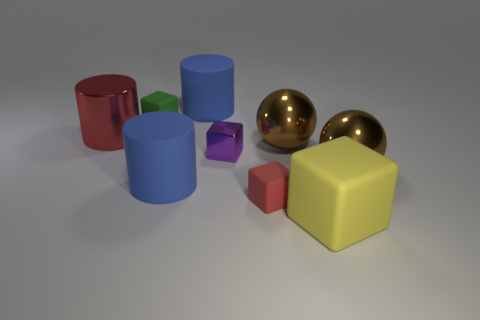Subtract all tiny green matte blocks. How many blocks are left? 3 Subtract all purple blocks. How many blocks are left? 3 Subtract all gray cubes. Subtract all red cylinders. How many cubes are left? 4 Add 1 small purple cubes. How many objects exist? 10 Subtract all cylinders. How many objects are left? 6 Add 2 red metal cylinders. How many red metal cylinders exist? 3 Subtract 0 purple spheres. How many objects are left? 9 Subtract all red rubber objects. Subtract all red things. How many objects are left? 6 Add 9 yellow things. How many yellow things are left? 10 